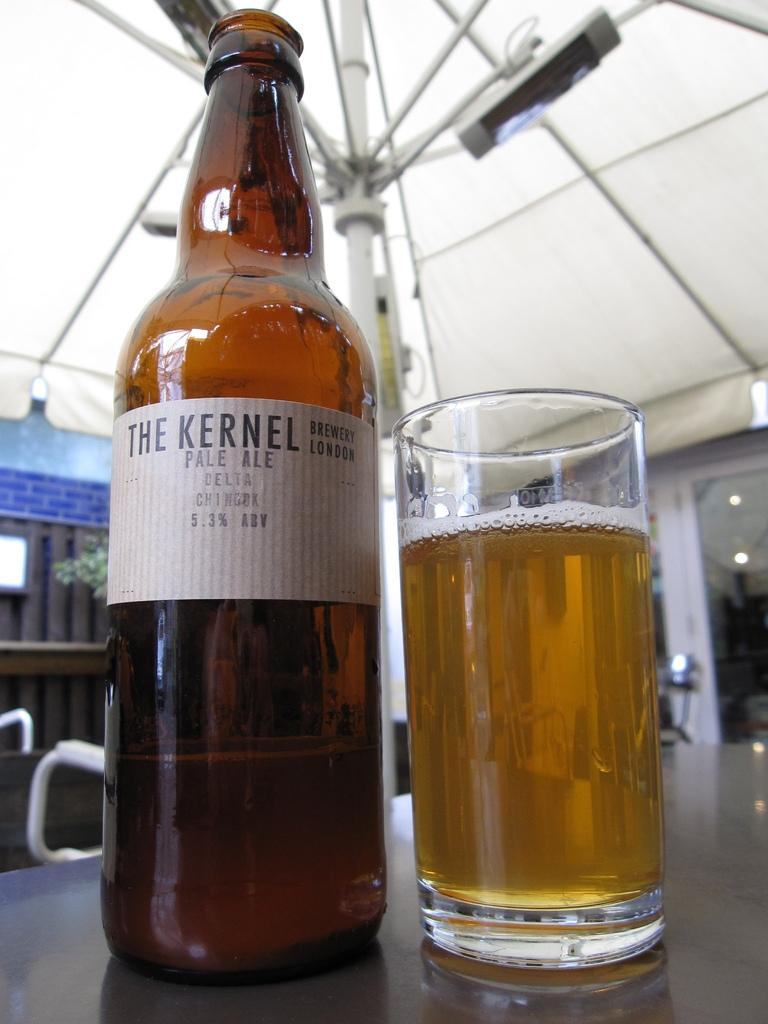<image>
Render a clear and concise summary of the photo. A bottle of The Kernal Pale Ale next to a glass of beer. 